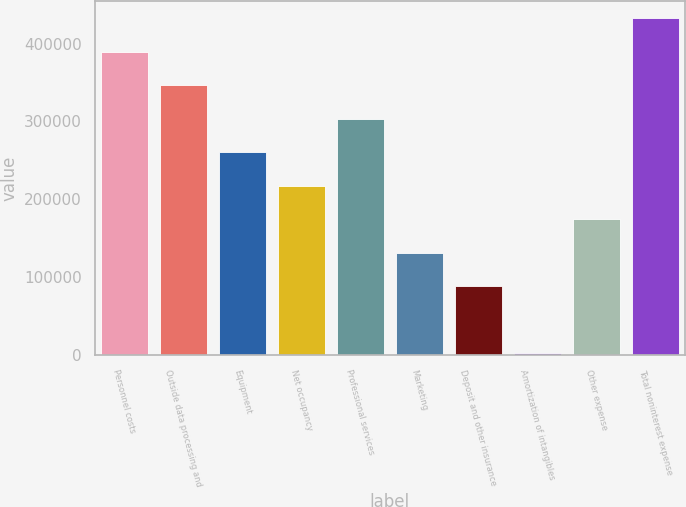Convert chart to OTSL. <chart><loc_0><loc_0><loc_500><loc_500><bar_chart><fcel>Personnel costs<fcel>Outside data processing and<fcel>Equipment<fcel>Net occupancy<fcel>Professional services<fcel>Marketing<fcel>Deposit and other insurance<fcel>Amortization of intangibles<fcel>Other expense<fcel>Total noninterest expense<nl><fcel>389578<fcel>346579<fcel>260582<fcel>217583<fcel>303581<fcel>131585<fcel>88586.6<fcel>2589<fcel>174584<fcel>432577<nl></chart> 